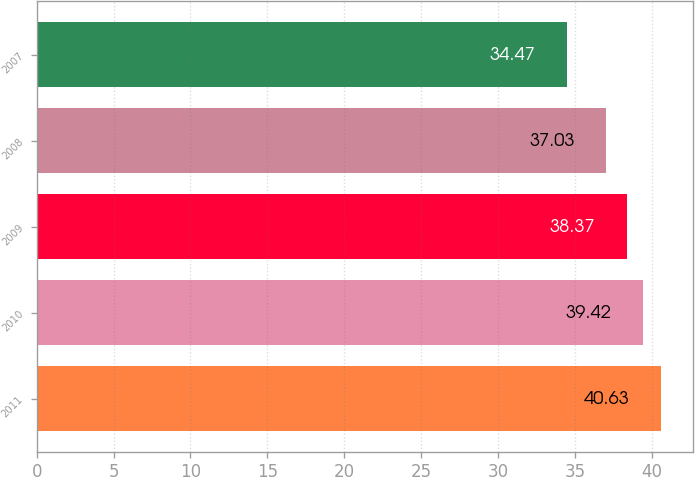<chart> <loc_0><loc_0><loc_500><loc_500><bar_chart><fcel>2011<fcel>2010<fcel>2009<fcel>2008<fcel>2007<nl><fcel>40.63<fcel>39.42<fcel>38.37<fcel>37.03<fcel>34.47<nl></chart> 